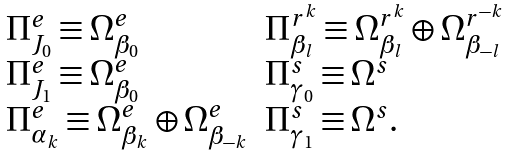<formula> <loc_0><loc_0><loc_500><loc_500>\begin{array} { l l } \Pi ^ { e } _ { J _ { 0 } } \equiv \Omega ^ { e } _ { \beta _ { 0 } } & \Pi ^ { r ^ { k } } _ { \beta _ { l } } \equiv \Omega ^ { r ^ { k } } _ { \beta _ { l } } \oplus \Omega ^ { r ^ { - k } } _ { \beta _ { - l } } \\ \Pi ^ { e } _ { J _ { 1 } } \equiv \Omega ^ { e } _ { \beta _ { 0 } } & \Pi ^ { s } _ { \gamma _ { 0 } } \equiv \Omega ^ { s } \\ \Pi ^ { e } _ { \alpha _ { k } } \equiv \Omega ^ { e } _ { \beta _ { k } } \oplus \Omega ^ { e } _ { \beta _ { - k } } & \Pi ^ { s } _ { \gamma _ { 1 } } \equiv \Omega ^ { s } . \end{array}</formula> 